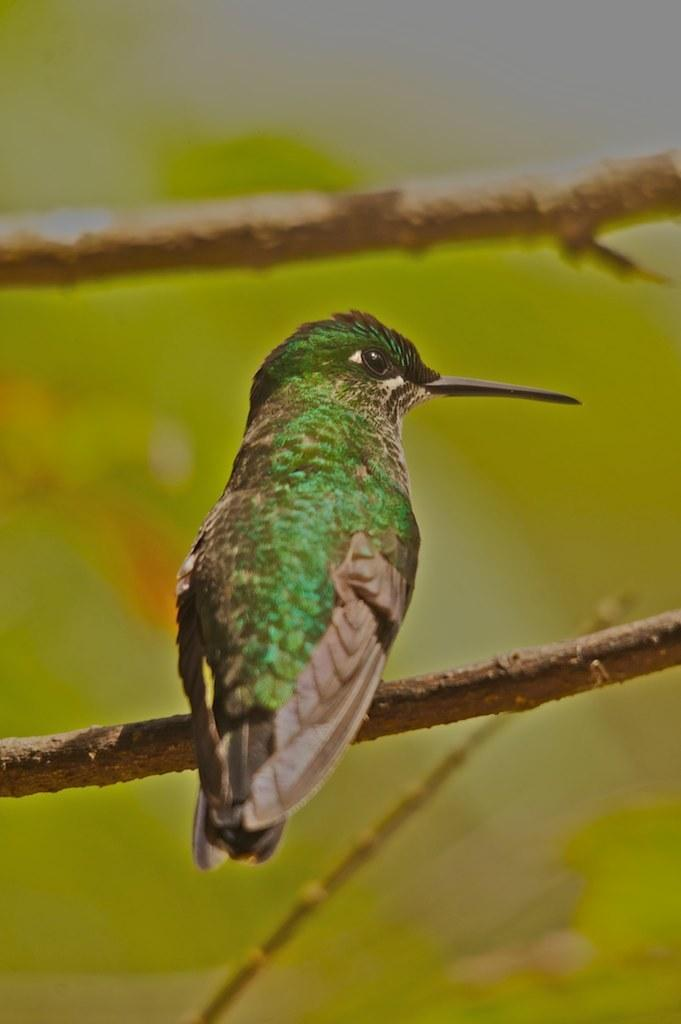What type of animal can be seen in the image? There is a bird in the image. Where is the bird located in the image? The bird is on the branch of a tree. Can you describe the background of the image? The background of the image is blurred. Is there a zoo in the background of the image? There is no mention of a zoo in the image or the provided facts. 